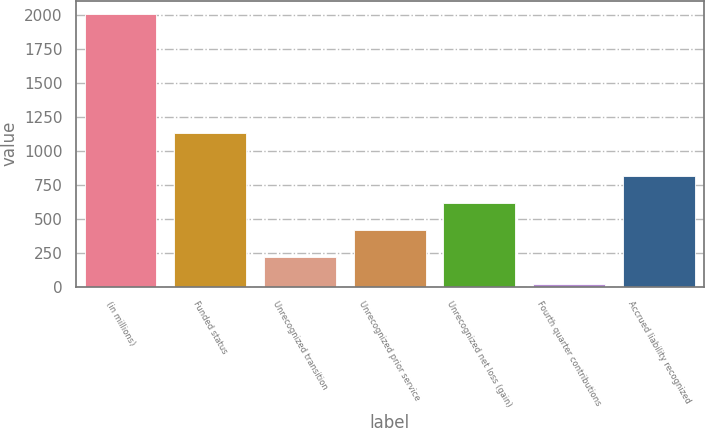Convert chart. <chart><loc_0><loc_0><loc_500><loc_500><bar_chart><fcel>(in millions)<fcel>Funded status<fcel>Unrecognized transition<fcel>Unrecognized prior service<fcel>Unrecognized net loss (gain)<fcel>Fourth quarter contributions<fcel>Accrued liability recognized<nl><fcel>2003<fcel>1133<fcel>217.4<fcel>415.8<fcel>614.2<fcel>19<fcel>812.6<nl></chart> 